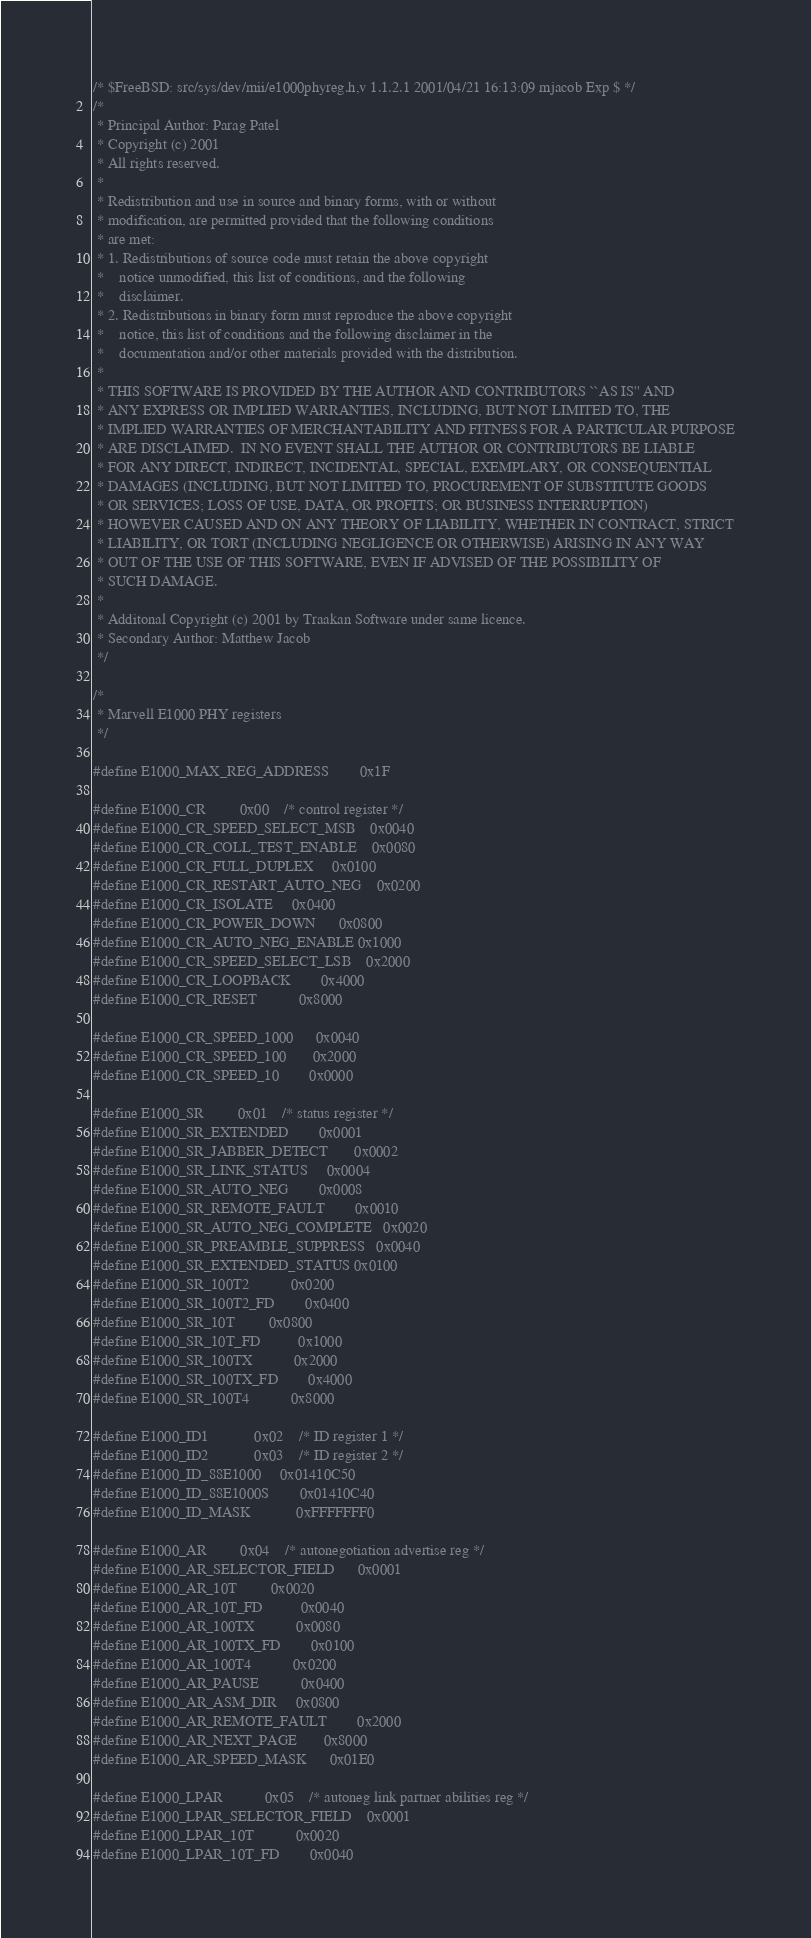Convert code to text. <code><loc_0><loc_0><loc_500><loc_500><_C_>/* $FreeBSD: src/sys/dev/mii/e1000phyreg.h,v 1.1.2.1 2001/04/21 16:13:09 mjacob Exp $ */
/*
 * Principal Author: Parag Patel
 * Copyright (c) 2001
 * All rights reserved.
 *
 * Redistribution and use in source and binary forms, with or without
 * modification, are permitted provided that the following conditions
 * are met:
 * 1. Redistributions of source code must retain the above copyright
 *    notice unmodified, this list of conditions, and the following
 *    disclaimer.
 * 2. Redistributions in binary form must reproduce the above copyright
 *    notice, this list of conditions and the following disclaimer in the
 *    documentation and/or other materials provided with the distribution.
 *
 * THIS SOFTWARE IS PROVIDED BY THE AUTHOR AND CONTRIBUTORS ``AS IS'' AND
 * ANY EXPRESS OR IMPLIED WARRANTIES, INCLUDING, BUT NOT LIMITED TO, THE
 * IMPLIED WARRANTIES OF MERCHANTABILITY AND FITNESS FOR A PARTICULAR PURPOSE
 * ARE DISCLAIMED.  IN NO EVENT SHALL THE AUTHOR OR CONTRIBUTORS BE LIABLE
 * FOR ANY DIRECT, INDIRECT, INCIDENTAL, SPECIAL, EXEMPLARY, OR CONSEQUENTIAL
 * DAMAGES (INCLUDING, BUT NOT LIMITED TO, PROCUREMENT OF SUBSTITUTE GOODS
 * OR SERVICES; LOSS OF USE, DATA, OR PROFITS; OR BUSINESS INTERRUPTION)
 * HOWEVER CAUSED AND ON ANY THEORY OF LIABILITY, WHETHER IN CONTRACT, STRICT
 * LIABILITY, OR TORT (INCLUDING NEGLIGENCE OR OTHERWISE) ARISING IN ANY WAY
 * OUT OF THE USE OF THIS SOFTWARE, EVEN IF ADVISED OF THE POSSIBILITY OF
 * SUCH DAMAGE.
 *
 * Additonal Copyright (c) 2001 by Traakan Software under same licence.
 * Secondary Author: Matthew Jacob
 */

/*
 * Marvell E1000 PHY registers
 */

#define E1000_MAX_REG_ADDRESS		0x1F

#define E1000_CR			0x00	/* control register */
#define E1000_CR_SPEED_SELECT_MSB	0x0040
#define E1000_CR_COLL_TEST_ENABLE	0x0080
#define E1000_CR_FULL_DUPLEX		0x0100
#define E1000_CR_RESTART_AUTO_NEG	0x0200
#define E1000_CR_ISOLATE		0x0400
#define E1000_CR_POWER_DOWN		0x0800
#define E1000_CR_AUTO_NEG_ENABLE	0x1000
#define E1000_CR_SPEED_SELECT_LSB	0x2000
#define E1000_CR_LOOPBACK		0x4000
#define E1000_CR_RESET			0x8000

#define E1000_CR_SPEED_1000		0x0040
#define E1000_CR_SPEED_100		0x2000
#define E1000_CR_SPEED_10		0x0000

#define E1000_SR			0x01	/* status register */
#define E1000_SR_EXTENDED		0x0001
#define E1000_SR_JABBER_DETECT		0x0002
#define E1000_SR_LINK_STATUS		0x0004
#define E1000_SR_AUTO_NEG		0x0008
#define E1000_SR_REMOTE_FAULT		0x0010
#define E1000_SR_AUTO_NEG_COMPLETE	0x0020
#define E1000_SR_PREAMBLE_SUPPRESS	0x0040
#define E1000_SR_EXTENDED_STATUS	0x0100
#define E1000_SR_100T2			0x0200
#define E1000_SR_100T2_FD		0x0400
#define E1000_SR_10T			0x0800
#define E1000_SR_10T_FD			0x1000
#define E1000_SR_100TX			0x2000
#define E1000_SR_100TX_FD		0x4000
#define E1000_SR_100T4			0x8000

#define E1000_ID1			0x02	/* ID register 1 */
#define E1000_ID2			0x03	/* ID register 2 */
#define E1000_ID_88E1000		0x01410C50
#define E1000_ID_88E1000S		0x01410C40
#define E1000_ID_MASK			0xFFFFFFF0

#define E1000_AR			0x04	/* autonegotiation advertise reg */
#define E1000_AR_SELECTOR_FIELD		0x0001
#define E1000_AR_10T			0x0020
#define E1000_AR_10T_FD			0x0040
#define E1000_AR_100TX			0x0080
#define E1000_AR_100TX_FD		0x0100
#define E1000_AR_100T4			0x0200
#define E1000_AR_PAUSE			0x0400
#define E1000_AR_ASM_DIR		0x0800
#define E1000_AR_REMOTE_FAULT		0x2000
#define E1000_AR_NEXT_PAGE		0x8000
#define E1000_AR_SPEED_MASK		0x01E0

#define E1000_LPAR			0x05	/* autoneg link partner abilities reg */
#define E1000_LPAR_SELECTOR_FIELD	0x0001
#define E1000_LPAR_10T			0x0020
#define E1000_LPAR_10T_FD		0x0040</code> 